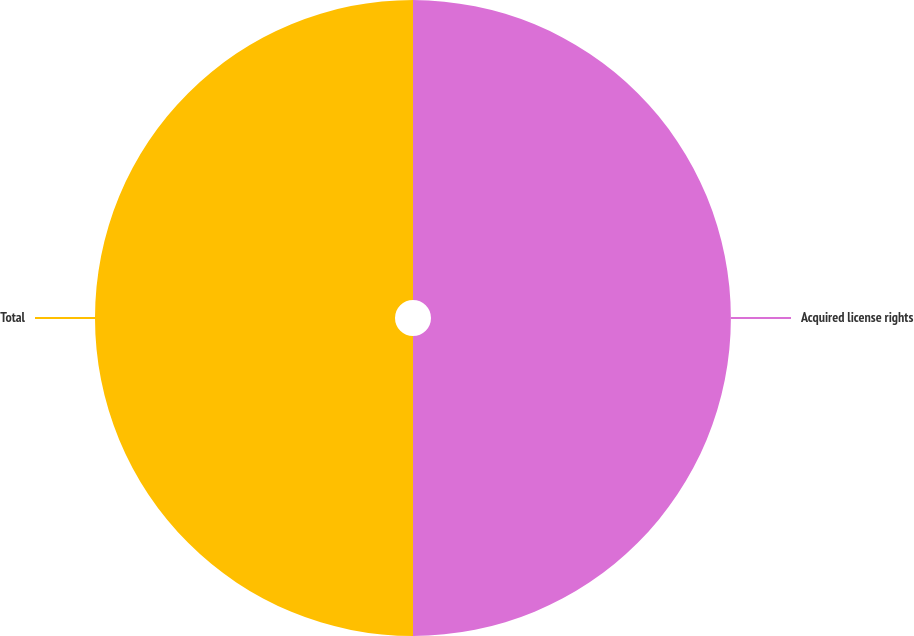<chart> <loc_0><loc_0><loc_500><loc_500><pie_chart><fcel>Acquired license rights<fcel>Total<nl><fcel>49.99%<fcel>50.01%<nl></chart> 